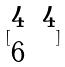Convert formula to latex. <formula><loc_0><loc_0><loc_500><loc_500>[ \begin{matrix} 4 & 4 \\ 6 \end{matrix} ]</formula> 